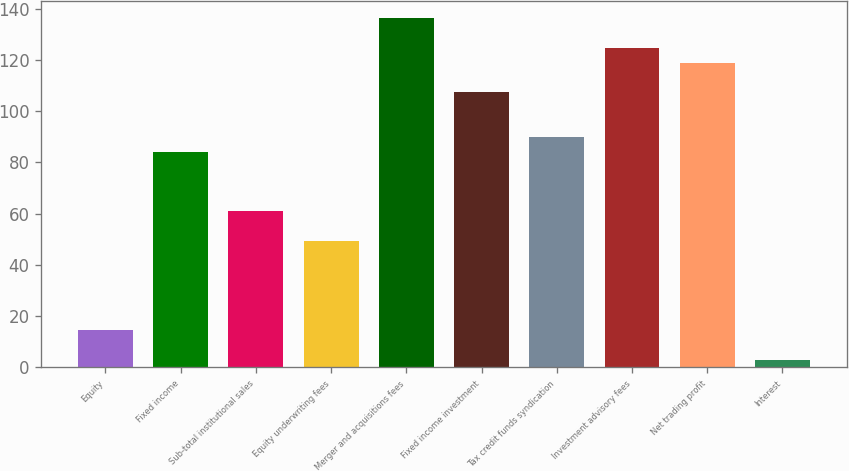Convert chart to OTSL. <chart><loc_0><loc_0><loc_500><loc_500><bar_chart><fcel>Equity<fcel>Fixed income<fcel>Sub-total institutional sales<fcel>Equity underwriting fees<fcel>Merger and acquisitions fees<fcel>Fixed income investment<fcel>Tax credit funds syndication<fcel>Investment advisory fees<fcel>Net trading profit<fcel>Interest<nl><fcel>14.6<fcel>84.2<fcel>61<fcel>49.4<fcel>136.4<fcel>107.4<fcel>90<fcel>124.8<fcel>119<fcel>3<nl></chart> 